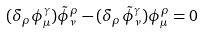Convert formula to latex. <formula><loc_0><loc_0><loc_500><loc_500>( \delta _ { \rho } \phi ^ { \gamma } _ { \mu } ) \tilde { \phi } ^ { \rho } _ { \nu } - ( \delta _ { \rho } \tilde { \phi } ^ { \gamma } _ { \nu } ) \phi ^ { \rho } _ { \mu } = 0</formula> 